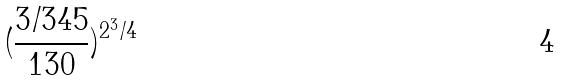Convert formula to latex. <formula><loc_0><loc_0><loc_500><loc_500>( \frac { 3 / 3 4 5 } { 1 3 0 } ) ^ { 2 ^ { 3 } / 4 }</formula> 